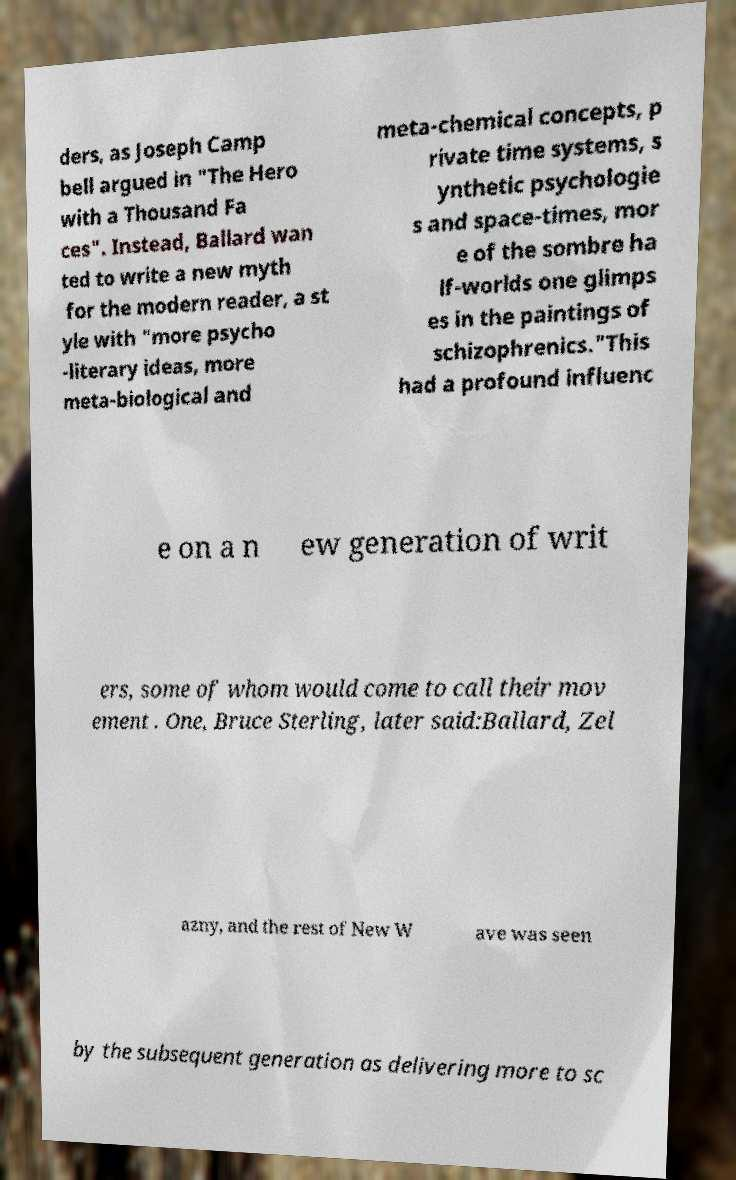Can you read and provide the text displayed in the image?This photo seems to have some interesting text. Can you extract and type it out for me? ders, as Joseph Camp bell argued in "The Hero with a Thousand Fa ces". Instead, Ballard wan ted to write a new myth for the modern reader, a st yle with "more psycho -literary ideas, more meta-biological and meta-chemical concepts, p rivate time systems, s ynthetic psychologie s and space-times, mor e of the sombre ha lf-worlds one glimps es in the paintings of schizophrenics."This had a profound influenc e on a n ew generation of writ ers, some of whom would come to call their mov ement . One, Bruce Sterling, later said:Ballard, Zel azny, and the rest of New W ave was seen by the subsequent generation as delivering more to sc 